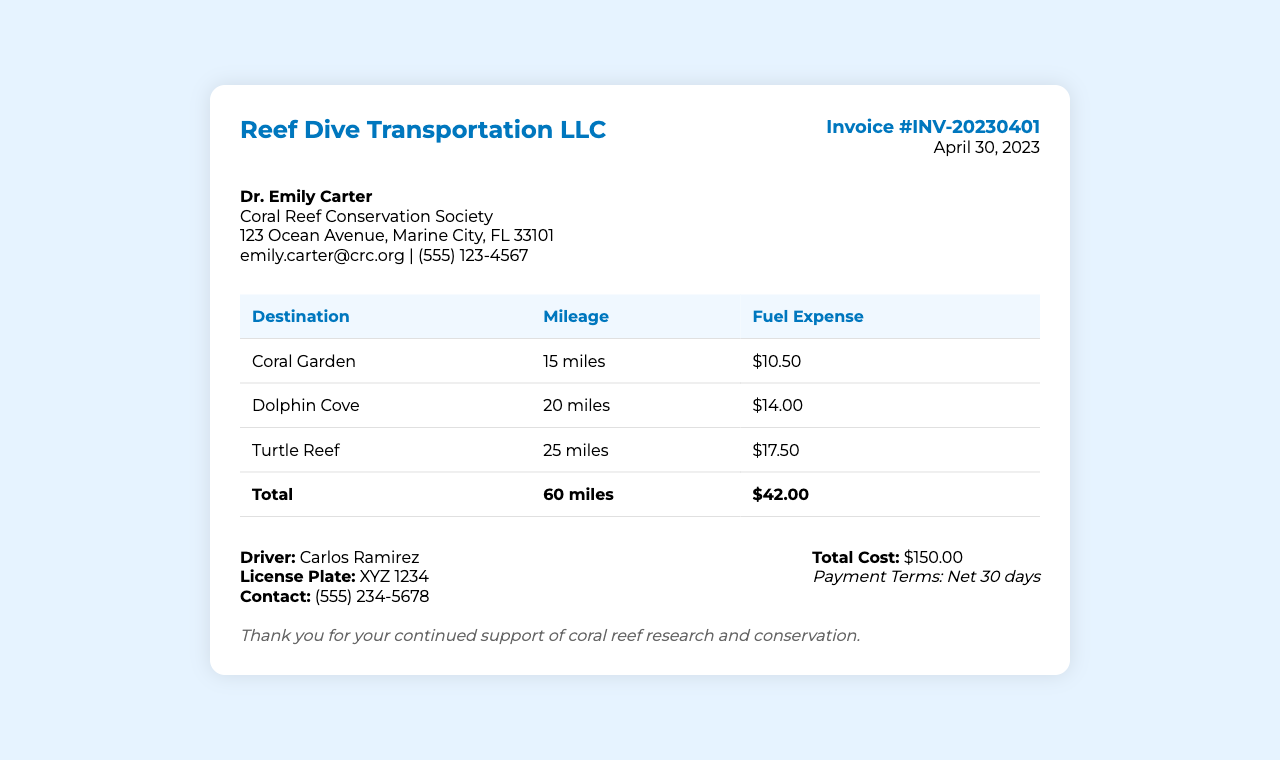what is the invoice number? The invoice number is indicated in the invoice details section.
Answer: INV-20230401 who is the driver? The driver's name is provided in the summary section of the invoice.
Answer: Carlos Ramirez what is the total mileage? The total mileage is calculated from the mileage of all the destinations listed in the table.
Answer: 60 miles what is the fuel expense for Turtle Reef? The fuel expense for Turtle Reef is listed in the table under the respective destination.
Answer: $17.50 what is the total cost? The total cost is specified in the summary section of the invoice.
Answer: $150.00 what are the payment terms? The payment terms are noted in the summary section below the total cost.
Answer: Net 30 days how many miles are to Dolphin Cove? The mileage to Dolphin Cove is stated in the mileage column of the table.
Answer: 20 miles what is the contact number for the driver? The driver's contact number is mentioned in the summary section.
Answer: (555) 234-5678 